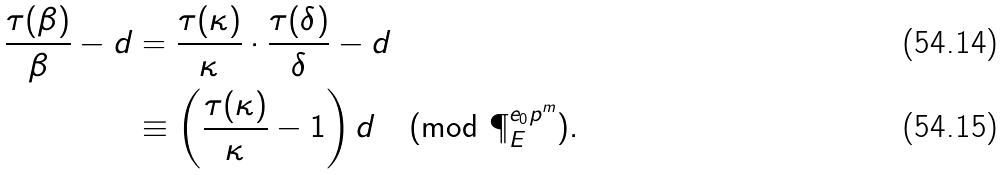<formula> <loc_0><loc_0><loc_500><loc_500>\frac { \tau ( \beta ) } { \beta } - d & = \frac { \tau ( \kappa ) } { \kappa } \cdot \frac { \tau ( \delta ) } { \delta } - d \\ & \equiv \left ( \frac { \tau ( \kappa ) } { \kappa } - 1 \right ) d \pmod { \P _ { E } ^ { e _ { 0 } p ^ { m } } } .</formula> 